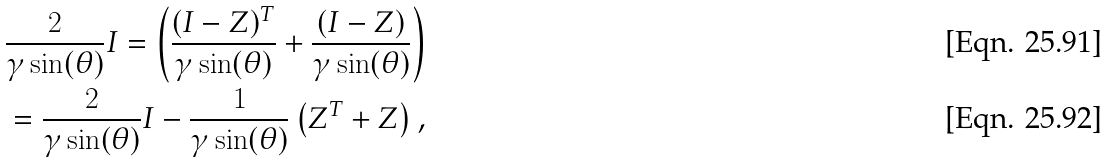Convert formula to latex. <formula><loc_0><loc_0><loc_500><loc_500>& \frac { 2 } { \gamma \sin ( \theta ) } I = \left ( \frac { ( I - Z ) ^ { T } } { \gamma \sin ( \theta ) } + \frac { ( I - Z ) } { \gamma \sin ( \theta ) } \right ) \\ & = \frac { 2 } { \gamma \sin ( \theta ) } I - \frac { 1 } { \gamma \sin ( \theta ) } \left ( Z ^ { T } + Z \right ) ,</formula> 